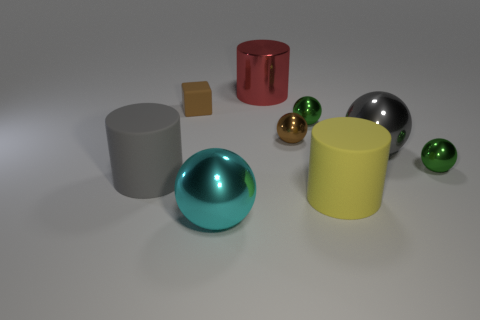Subtract all yellow balls. Subtract all red cylinders. How many balls are left? 5 Add 1 large yellow rubber objects. How many objects exist? 10 Subtract all spheres. How many objects are left? 4 Subtract all tiny metal cylinders. Subtract all rubber cylinders. How many objects are left? 7 Add 8 green spheres. How many green spheres are left? 10 Add 1 yellow rubber cylinders. How many yellow rubber cylinders exist? 2 Subtract 1 red cylinders. How many objects are left? 8 